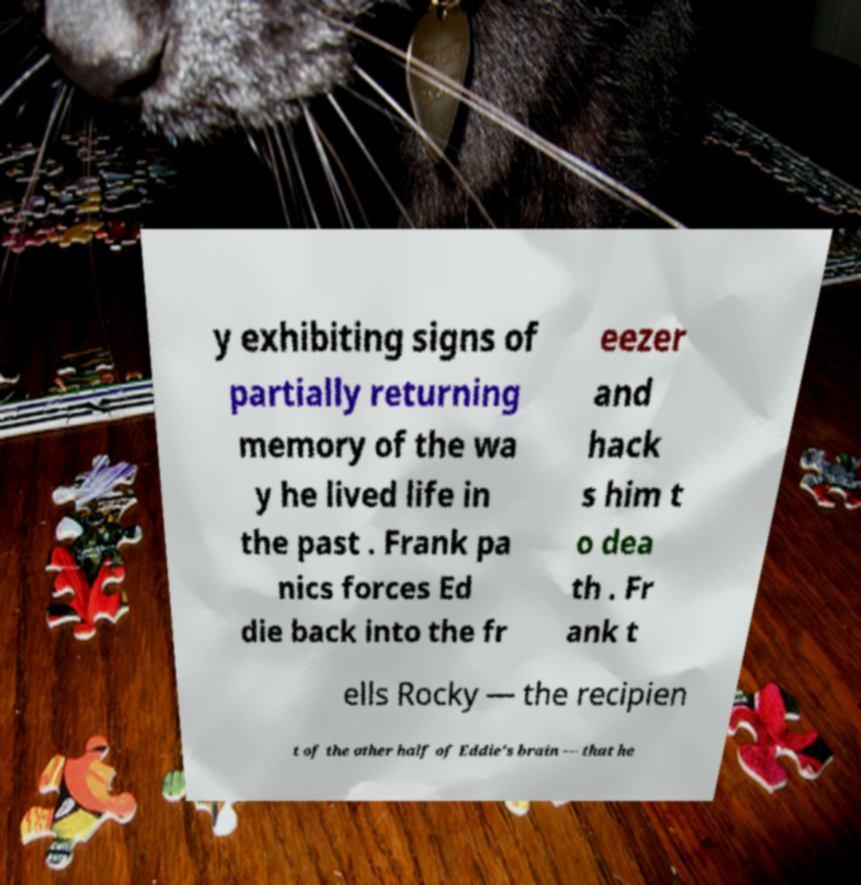There's text embedded in this image that I need extracted. Can you transcribe it verbatim? y exhibiting signs of partially returning memory of the wa y he lived life in the past . Frank pa nics forces Ed die back into the fr eezer and hack s him t o dea th . Fr ank t ells Rocky — the recipien t of the other half of Eddie's brain — that he 